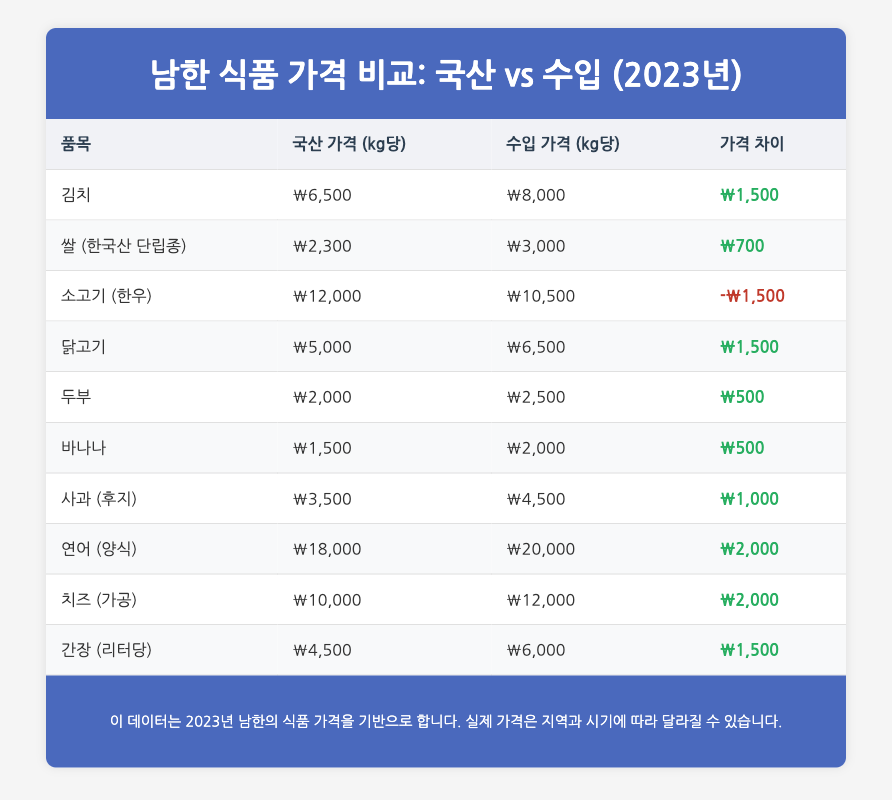What is the local price of Kimchi per kg? The table specifies the local price of Kimchi as ₩6,500.
Answer: ₩6,500 What is the price difference between local and imported Bananas? The price difference for Bananas is calculated from the table as ₩2,000 (imported) - ₩1,500 (local) = ₩500.
Answer: ₩500 Is the imported price of Beef higher than that of Chicken? From the table, the imported price of Beef is ₩10,500, while the imported price of Chicken is ₩6,500. Thus, the imported price of Beef is higher.
Answer: Yes What is the average local price of the food items listed in the table? To find the average local price, we add all local prices: ₩6,500 + ₩2,300 + ₩12,000 + ₩5,000 + ₩2,000 + ₩1,500 + ₩3,500 + ₩18,000 + ₩10,000 + ₩4,500 = ₩65,300; then divide by the number of items (10). Therefore, the average local price is ₩65,300 / 10 = ₩6,530.
Answer: ₩6,530 Which imported food item has the highest price difference with its local counterpart? By evaluating the price differences, Salmon (₩20,000 - ₩18,000 = ₩2,000), Cheese (₩12,000 - ₩10,000 = ₩2,000) both show high differences, but the highest local price is seen in Salmon and Cheese, both with a difference of ₩2,000.
Answer: Salmon and Cheese Is the local price of Korean Short Grain Rice lower than the local price of Tofu? The local price of Korean Short Grain Rice is ₩2,300, while Tofu is ₩2,000. Therefore, the local price of Rice is higher.
Answer: No 